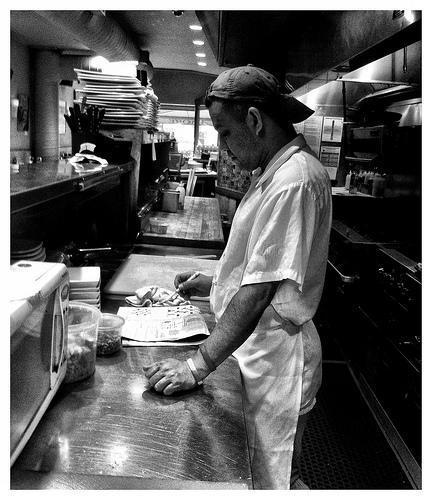How many people are there?
Give a very brief answer. 1. 